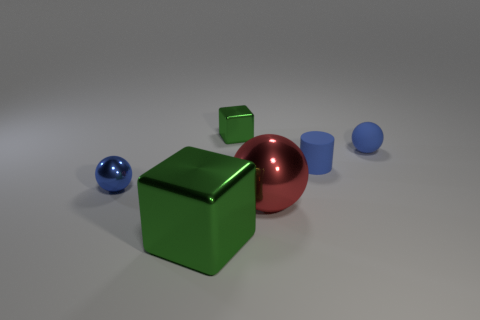What can you infer about the material of the blue sphere? The blue sphere exhibits a glossy surface, suggesting that it is likely made of a material similar to plastic or polished metal, giving it a reflective appearance.  How is the lighting affecting the appearance of the objects? The lighting plays a crucial role in defining the objects' dimensions and textures. It casts soft shadows and highlights the reflective surfaces, enhancing the objects' three-dimensional forms and contributing to a sense of depth in the scene. 